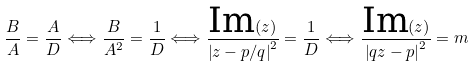Convert formula to latex. <formula><loc_0><loc_0><loc_500><loc_500>\frac { B } { A } = \frac { A } { D } \Longleftrightarrow \frac { B } { A ^ { 2 } } = \frac { 1 } { D } \Longleftrightarrow \frac { \text {Im} ( z ) } { \left | z - p / q \right | ^ { 2 } } = \frac { 1 } { D } \Longleftrightarrow \frac { \text {Im} ( z ) } { \left | q z - p \right | ^ { 2 } } = m</formula> 